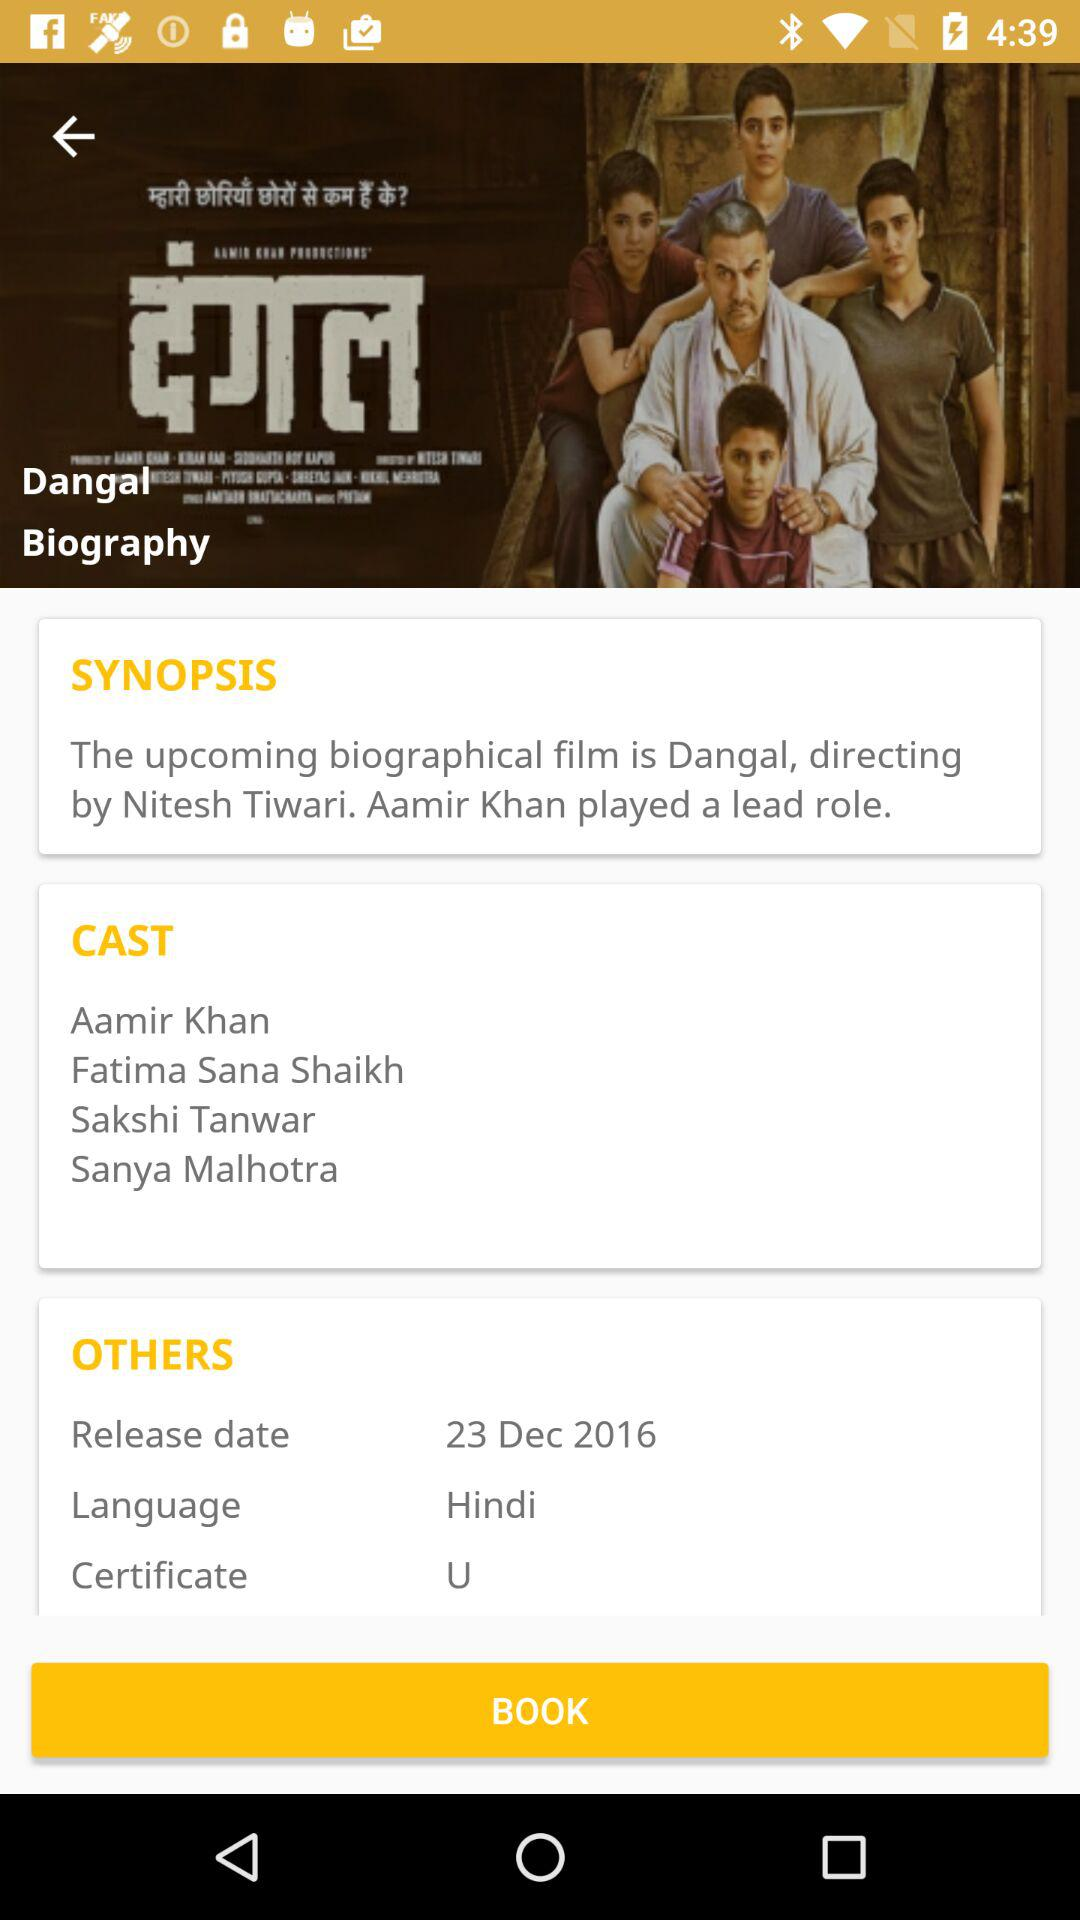Which type of certificate is given to the "Dangal" movie? The type of certificate given to the "Dangal" movie is U. 